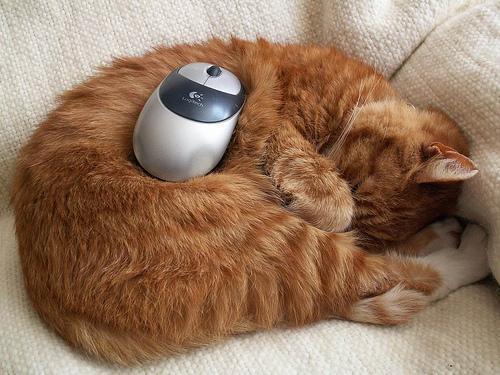How many birds are going to fly there in the image?
Give a very brief answer. 0. 